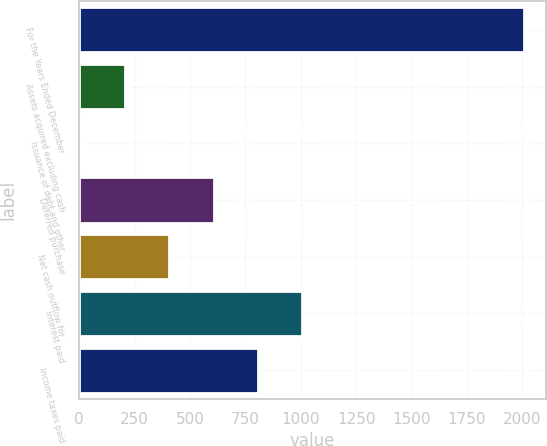Convert chart. <chart><loc_0><loc_0><loc_500><loc_500><bar_chart><fcel>For the Years Ended December<fcel>Assets acquired excluding cash<fcel>Issuance of debt and other<fcel>Deferred purchase<fcel>Net cash outflow for<fcel>Interest paid<fcel>Income taxes paid<nl><fcel>2005<fcel>207.7<fcel>8<fcel>607.1<fcel>407.4<fcel>1006.5<fcel>806.8<nl></chart> 